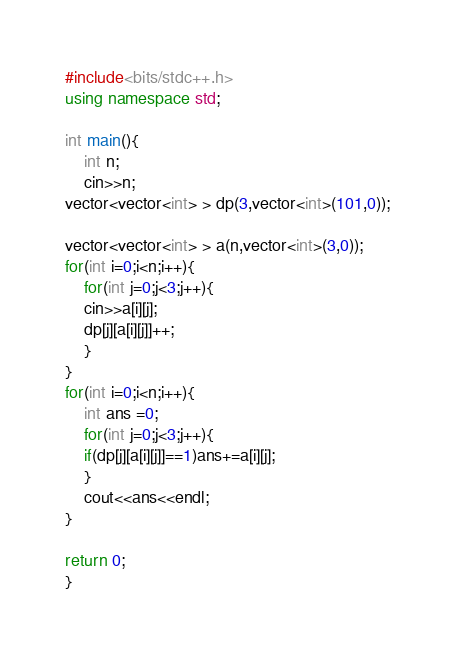<code> <loc_0><loc_0><loc_500><loc_500><_C++_>#include<bits/stdc++.h>
using namespace std;

int main(){
	int n;
	cin>>n;
vector<vector<int> > dp(3,vector<int>(101,0));

vector<vector<int> > a(n,vector<int>(3,0));
for(int i=0;i<n;i++){
	for(int j=0;j<3;j++){
	cin>>a[i][j];
	dp[j][a[i][j]]++;
	}
}
for(int i=0;i<n;i++){
	int ans =0;
	for(int j=0;j<3;j++){
	if(dp[j][a[i][j]]==1)ans+=a[i][j];
	}
	cout<<ans<<endl;
}

return 0;
}

</code> 